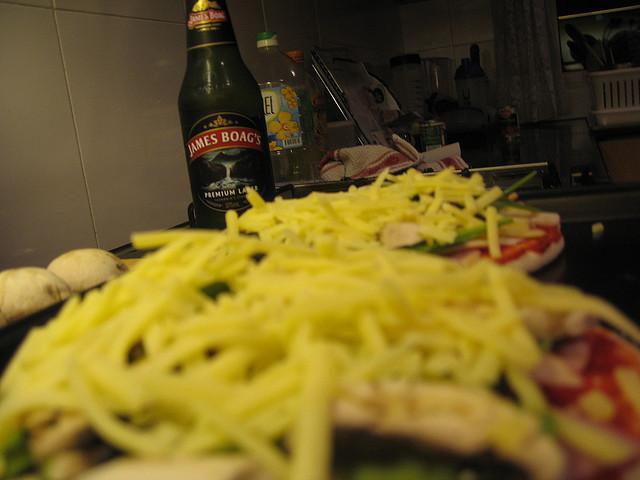How many bottles are there?
Give a very brief answer. 2. How many pizzas can be seen?
Give a very brief answer. 2. 